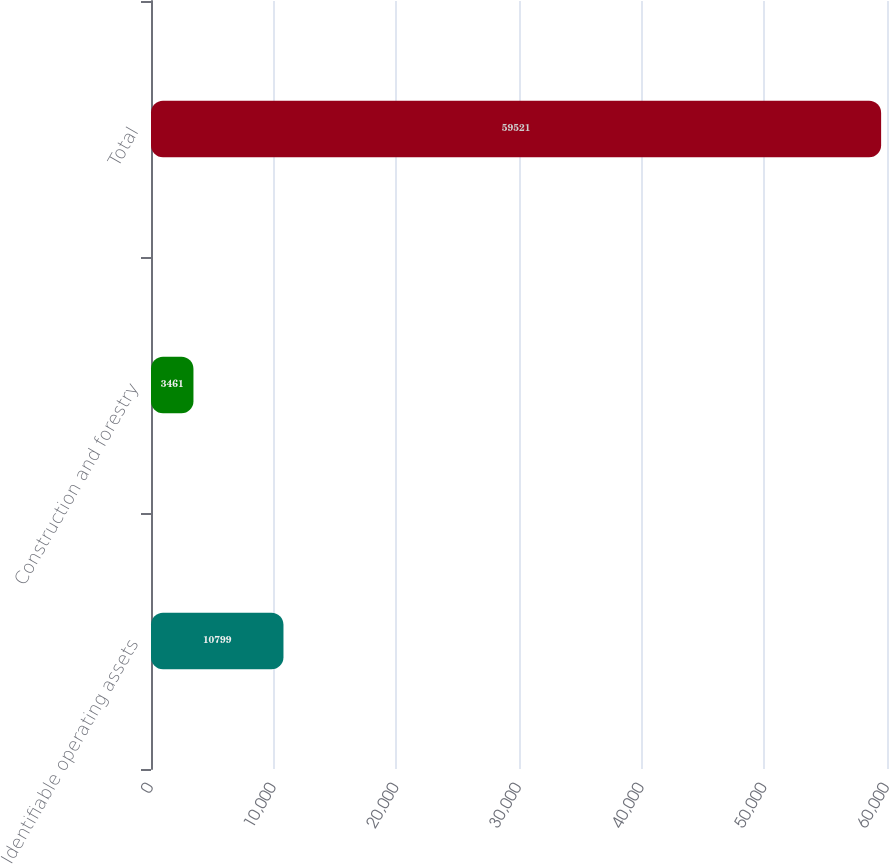Convert chart to OTSL. <chart><loc_0><loc_0><loc_500><loc_500><bar_chart><fcel>Identifiable operating assets<fcel>Construction and forestry<fcel>Total<nl><fcel>10799<fcel>3461<fcel>59521<nl></chart> 